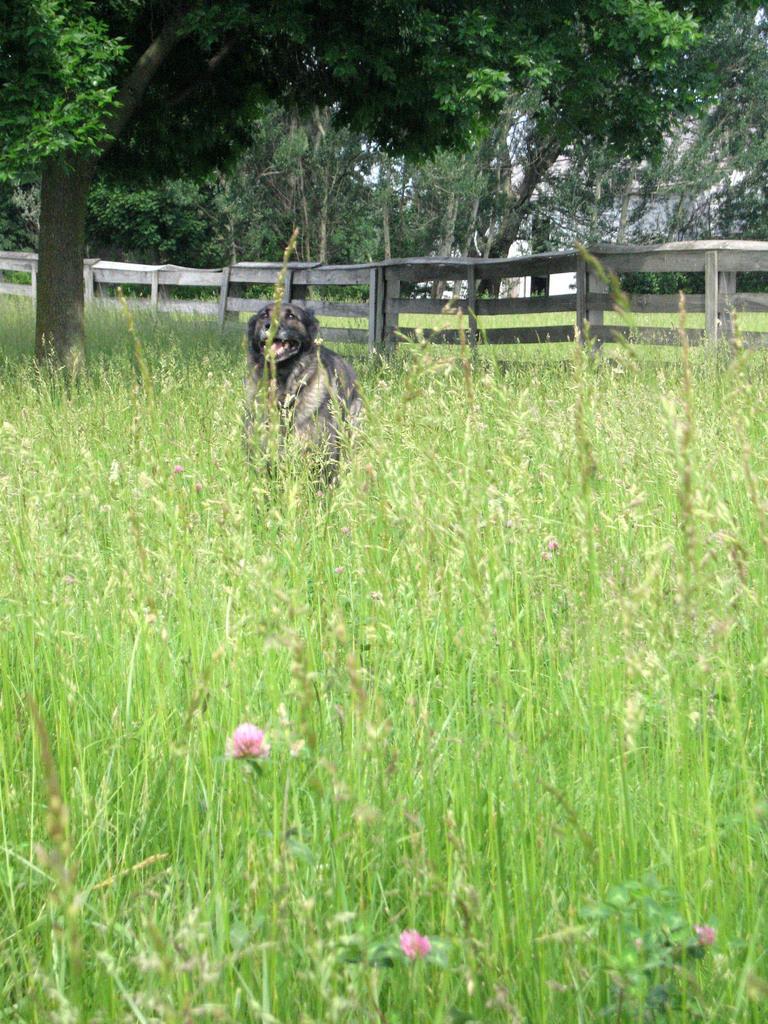In one or two sentences, can you explain what this image depicts? In this image on the ground there are plants. Here there is a dog. This is wooden fence. In the background there are trees. 